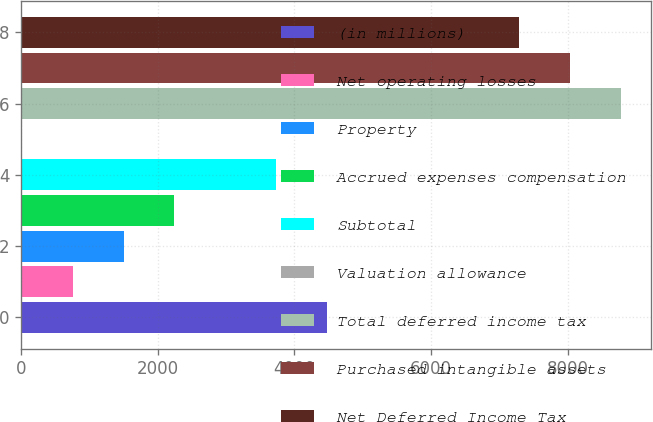Convert chart to OTSL. <chart><loc_0><loc_0><loc_500><loc_500><bar_chart><fcel>(in millions)<fcel>Net operating losses<fcel>Property<fcel>Accrued expenses compensation<fcel>Subtotal<fcel>Valuation allowance<fcel>Total deferred income tax<fcel>Purchased intangible assets<fcel>Net Deferred Income Tax<nl><fcel>4473.14<fcel>757.94<fcel>1500.98<fcel>2244.02<fcel>3730.1<fcel>14.9<fcel>8777.08<fcel>8034.04<fcel>7291<nl></chart> 